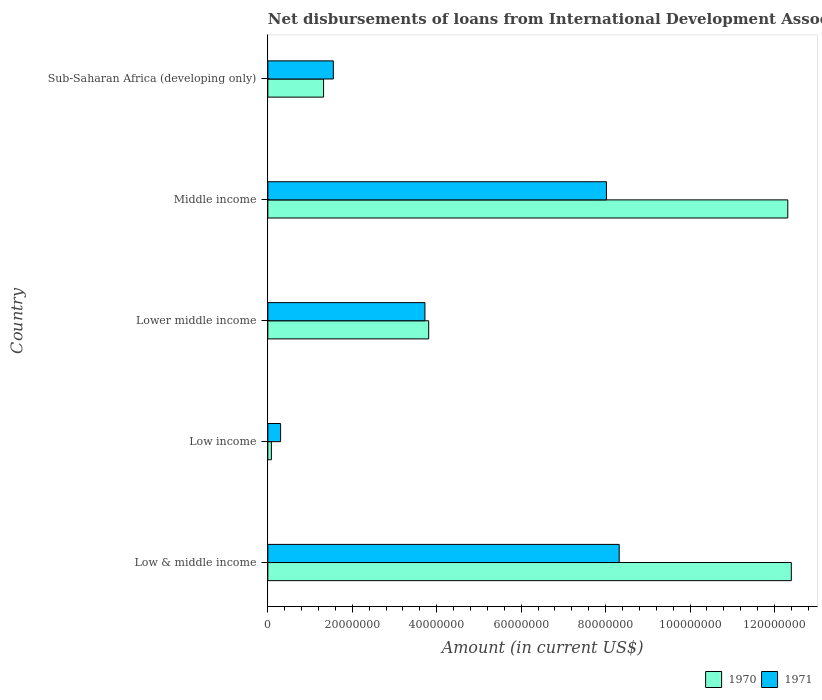How many groups of bars are there?
Offer a terse response. 5. Are the number of bars per tick equal to the number of legend labels?
Your response must be concise. Yes. Are the number of bars on each tick of the Y-axis equal?
Ensure brevity in your answer.  Yes. How many bars are there on the 1st tick from the bottom?
Make the answer very short. 2. What is the label of the 4th group of bars from the top?
Offer a very short reply. Low income. In how many cases, is the number of bars for a given country not equal to the number of legend labels?
Ensure brevity in your answer.  0. What is the amount of loans disbursed in 1971 in Low & middle income?
Your answer should be very brief. 8.32e+07. Across all countries, what is the maximum amount of loans disbursed in 1971?
Provide a short and direct response. 8.32e+07. Across all countries, what is the minimum amount of loans disbursed in 1970?
Make the answer very short. 8.35e+05. What is the total amount of loans disbursed in 1970 in the graph?
Provide a succinct answer. 2.99e+08. What is the difference between the amount of loans disbursed in 1970 in Low & middle income and that in Lower middle income?
Offer a terse response. 8.59e+07. What is the difference between the amount of loans disbursed in 1970 in Low income and the amount of loans disbursed in 1971 in Sub-Saharan Africa (developing only)?
Provide a short and direct response. -1.47e+07. What is the average amount of loans disbursed in 1970 per country?
Provide a short and direct response. 5.99e+07. What is the difference between the amount of loans disbursed in 1971 and amount of loans disbursed in 1970 in Low income?
Your response must be concise. 2.18e+06. What is the ratio of the amount of loans disbursed in 1971 in Low & middle income to that in Middle income?
Provide a short and direct response. 1.04. Is the amount of loans disbursed in 1971 in Low income less than that in Sub-Saharan Africa (developing only)?
Your response must be concise. Yes. Is the difference between the amount of loans disbursed in 1971 in Low income and Sub-Saharan Africa (developing only) greater than the difference between the amount of loans disbursed in 1970 in Low income and Sub-Saharan Africa (developing only)?
Your answer should be compact. No. What is the difference between the highest and the second highest amount of loans disbursed in 1970?
Provide a succinct answer. 8.35e+05. What is the difference between the highest and the lowest amount of loans disbursed in 1971?
Offer a terse response. 8.02e+07. Is the sum of the amount of loans disbursed in 1971 in Low income and Sub-Saharan Africa (developing only) greater than the maximum amount of loans disbursed in 1970 across all countries?
Your response must be concise. No. Are all the bars in the graph horizontal?
Give a very brief answer. Yes. How many countries are there in the graph?
Your answer should be compact. 5. What is the difference between two consecutive major ticks on the X-axis?
Provide a succinct answer. 2.00e+07. Does the graph contain any zero values?
Offer a very short reply. No. Does the graph contain grids?
Ensure brevity in your answer.  No. Where does the legend appear in the graph?
Your answer should be very brief. Bottom right. How many legend labels are there?
Your answer should be very brief. 2. How are the legend labels stacked?
Make the answer very short. Horizontal. What is the title of the graph?
Your answer should be compact. Net disbursements of loans from International Development Association. What is the label or title of the X-axis?
Keep it short and to the point. Amount (in current US$). What is the label or title of the Y-axis?
Give a very brief answer. Country. What is the Amount (in current US$) of 1970 in Low & middle income?
Offer a very short reply. 1.24e+08. What is the Amount (in current US$) in 1971 in Low & middle income?
Your answer should be compact. 8.32e+07. What is the Amount (in current US$) of 1970 in Low income?
Ensure brevity in your answer.  8.35e+05. What is the Amount (in current US$) of 1971 in Low income?
Provide a succinct answer. 3.02e+06. What is the Amount (in current US$) in 1970 in Lower middle income?
Provide a short and direct response. 3.81e+07. What is the Amount (in current US$) of 1971 in Lower middle income?
Offer a terse response. 3.72e+07. What is the Amount (in current US$) in 1970 in Middle income?
Provide a succinct answer. 1.23e+08. What is the Amount (in current US$) in 1971 in Middle income?
Keep it short and to the point. 8.02e+07. What is the Amount (in current US$) in 1970 in Sub-Saharan Africa (developing only)?
Provide a short and direct response. 1.32e+07. What is the Amount (in current US$) in 1971 in Sub-Saharan Africa (developing only)?
Offer a very short reply. 1.55e+07. Across all countries, what is the maximum Amount (in current US$) in 1970?
Ensure brevity in your answer.  1.24e+08. Across all countries, what is the maximum Amount (in current US$) in 1971?
Offer a terse response. 8.32e+07. Across all countries, what is the minimum Amount (in current US$) of 1970?
Keep it short and to the point. 8.35e+05. Across all countries, what is the minimum Amount (in current US$) in 1971?
Provide a short and direct response. 3.02e+06. What is the total Amount (in current US$) in 1970 in the graph?
Provide a short and direct response. 2.99e+08. What is the total Amount (in current US$) of 1971 in the graph?
Offer a very short reply. 2.19e+08. What is the difference between the Amount (in current US$) of 1970 in Low & middle income and that in Low income?
Provide a succinct answer. 1.23e+08. What is the difference between the Amount (in current US$) of 1971 in Low & middle income and that in Low income?
Your response must be concise. 8.02e+07. What is the difference between the Amount (in current US$) in 1970 in Low & middle income and that in Lower middle income?
Ensure brevity in your answer.  8.59e+07. What is the difference between the Amount (in current US$) in 1971 in Low & middle income and that in Lower middle income?
Ensure brevity in your answer.  4.60e+07. What is the difference between the Amount (in current US$) in 1970 in Low & middle income and that in Middle income?
Keep it short and to the point. 8.35e+05. What is the difference between the Amount (in current US$) of 1971 in Low & middle income and that in Middle income?
Ensure brevity in your answer.  3.02e+06. What is the difference between the Amount (in current US$) of 1970 in Low & middle income and that in Sub-Saharan Africa (developing only)?
Provide a short and direct response. 1.11e+08. What is the difference between the Amount (in current US$) of 1971 in Low & middle income and that in Sub-Saharan Africa (developing only)?
Give a very brief answer. 6.77e+07. What is the difference between the Amount (in current US$) of 1970 in Low income and that in Lower middle income?
Your answer should be very brief. -3.73e+07. What is the difference between the Amount (in current US$) in 1971 in Low income and that in Lower middle income?
Your answer should be very brief. -3.42e+07. What is the difference between the Amount (in current US$) of 1970 in Low income and that in Middle income?
Provide a short and direct response. -1.22e+08. What is the difference between the Amount (in current US$) of 1971 in Low income and that in Middle income?
Make the answer very short. -7.72e+07. What is the difference between the Amount (in current US$) in 1970 in Low income and that in Sub-Saharan Africa (developing only)?
Make the answer very short. -1.24e+07. What is the difference between the Amount (in current US$) of 1971 in Low income and that in Sub-Saharan Africa (developing only)?
Provide a short and direct response. -1.25e+07. What is the difference between the Amount (in current US$) in 1970 in Lower middle income and that in Middle income?
Make the answer very short. -8.51e+07. What is the difference between the Amount (in current US$) of 1971 in Lower middle income and that in Middle income?
Your answer should be compact. -4.30e+07. What is the difference between the Amount (in current US$) of 1970 in Lower middle income and that in Sub-Saharan Africa (developing only)?
Offer a very short reply. 2.49e+07. What is the difference between the Amount (in current US$) in 1971 in Lower middle income and that in Sub-Saharan Africa (developing only)?
Your response must be concise. 2.17e+07. What is the difference between the Amount (in current US$) in 1970 in Middle income and that in Sub-Saharan Africa (developing only)?
Make the answer very short. 1.10e+08. What is the difference between the Amount (in current US$) of 1971 in Middle income and that in Sub-Saharan Africa (developing only)?
Provide a succinct answer. 6.47e+07. What is the difference between the Amount (in current US$) in 1970 in Low & middle income and the Amount (in current US$) in 1971 in Low income?
Your answer should be compact. 1.21e+08. What is the difference between the Amount (in current US$) of 1970 in Low & middle income and the Amount (in current US$) of 1971 in Lower middle income?
Provide a short and direct response. 8.68e+07. What is the difference between the Amount (in current US$) of 1970 in Low & middle income and the Amount (in current US$) of 1971 in Middle income?
Your answer should be compact. 4.38e+07. What is the difference between the Amount (in current US$) in 1970 in Low & middle income and the Amount (in current US$) in 1971 in Sub-Saharan Africa (developing only)?
Offer a very short reply. 1.08e+08. What is the difference between the Amount (in current US$) of 1970 in Low income and the Amount (in current US$) of 1971 in Lower middle income?
Offer a terse response. -3.64e+07. What is the difference between the Amount (in current US$) in 1970 in Low income and the Amount (in current US$) in 1971 in Middle income?
Offer a very short reply. -7.94e+07. What is the difference between the Amount (in current US$) of 1970 in Low income and the Amount (in current US$) of 1971 in Sub-Saharan Africa (developing only)?
Your answer should be compact. -1.47e+07. What is the difference between the Amount (in current US$) of 1970 in Lower middle income and the Amount (in current US$) of 1971 in Middle income?
Give a very brief answer. -4.21e+07. What is the difference between the Amount (in current US$) in 1970 in Lower middle income and the Amount (in current US$) in 1971 in Sub-Saharan Africa (developing only)?
Offer a very short reply. 2.26e+07. What is the difference between the Amount (in current US$) of 1970 in Middle income and the Amount (in current US$) of 1971 in Sub-Saharan Africa (developing only)?
Offer a terse response. 1.08e+08. What is the average Amount (in current US$) in 1970 per country?
Your answer should be compact. 5.99e+07. What is the average Amount (in current US$) in 1971 per country?
Keep it short and to the point. 4.38e+07. What is the difference between the Amount (in current US$) in 1970 and Amount (in current US$) in 1971 in Low & middle income?
Your answer should be very brief. 4.08e+07. What is the difference between the Amount (in current US$) in 1970 and Amount (in current US$) in 1971 in Low income?
Keep it short and to the point. -2.18e+06. What is the difference between the Amount (in current US$) of 1970 and Amount (in current US$) of 1971 in Lower middle income?
Offer a very short reply. 8.88e+05. What is the difference between the Amount (in current US$) of 1970 and Amount (in current US$) of 1971 in Middle income?
Make the answer very short. 4.30e+07. What is the difference between the Amount (in current US$) of 1970 and Amount (in current US$) of 1971 in Sub-Saharan Africa (developing only)?
Give a very brief answer. -2.31e+06. What is the ratio of the Amount (in current US$) in 1970 in Low & middle income to that in Low income?
Provide a short and direct response. 148.5. What is the ratio of the Amount (in current US$) of 1971 in Low & middle income to that in Low income?
Make the answer very short. 27.59. What is the ratio of the Amount (in current US$) of 1970 in Low & middle income to that in Lower middle income?
Provide a short and direct response. 3.25. What is the ratio of the Amount (in current US$) of 1971 in Low & middle income to that in Lower middle income?
Offer a terse response. 2.24. What is the ratio of the Amount (in current US$) in 1970 in Low & middle income to that in Middle income?
Give a very brief answer. 1.01. What is the ratio of the Amount (in current US$) in 1971 in Low & middle income to that in Middle income?
Ensure brevity in your answer.  1.04. What is the ratio of the Amount (in current US$) of 1970 in Low & middle income to that in Sub-Saharan Africa (developing only)?
Your answer should be very brief. 9.39. What is the ratio of the Amount (in current US$) in 1971 in Low & middle income to that in Sub-Saharan Africa (developing only)?
Ensure brevity in your answer.  5.36. What is the ratio of the Amount (in current US$) in 1970 in Low income to that in Lower middle income?
Offer a terse response. 0.02. What is the ratio of the Amount (in current US$) of 1971 in Low income to that in Lower middle income?
Ensure brevity in your answer.  0.08. What is the ratio of the Amount (in current US$) of 1970 in Low income to that in Middle income?
Ensure brevity in your answer.  0.01. What is the ratio of the Amount (in current US$) in 1971 in Low income to that in Middle income?
Offer a very short reply. 0.04. What is the ratio of the Amount (in current US$) of 1970 in Low income to that in Sub-Saharan Africa (developing only)?
Offer a terse response. 0.06. What is the ratio of the Amount (in current US$) of 1971 in Low income to that in Sub-Saharan Africa (developing only)?
Give a very brief answer. 0.19. What is the ratio of the Amount (in current US$) of 1970 in Lower middle income to that in Middle income?
Give a very brief answer. 0.31. What is the ratio of the Amount (in current US$) in 1971 in Lower middle income to that in Middle income?
Ensure brevity in your answer.  0.46. What is the ratio of the Amount (in current US$) in 1970 in Lower middle income to that in Sub-Saharan Africa (developing only)?
Your answer should be very brief. 2.89. What is the ratio of the Amount (in current US$) in 1971 in Lower middle income to that in Sub-Saharan Africa (developing only)?
Ensure brevity in your answer.  2.4. What is the ratio of the Amount (in current US$) of 1970 in Middle income to that in Sub-Saharan Africa (developing only)?
Your answer should be very brief. 9.33. What is the ratio of the Amount (in current US$) in 1971 in Middle income to that in Sub-Saharan Africa (developing only)?
Your answer should be compact. 5.17. What is the difference between the highest and the second highest Amount (in current US$) in 1970?
Your response must be concise. 8.35e+05. What is the difference between the highest and the second highest Amount (in current US$) in 1971?
Provide a short and direct response. 3.02e+06. What is the difference between the highest and the lowest Amount (in current US$) in 1970?
Provide a succinct answer. 1.23e+08. What is the difference between the highest and the lowest Amount (in current US$) in 1971?
Ensure brevity in your answer.  8.02e+07. 